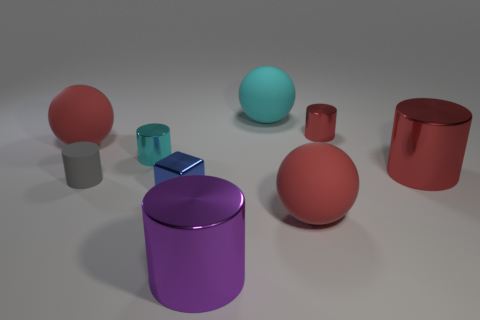There is a big matte sphere behind the big matte sphere that is to the left of the metal cylinder that is in front of the blue thing; what color is it?
Your answer should be very brief. Cyan. There is a cylinder behind the tiny cyan object; what color is it?
Provide a short and direct response. Red. What color is the metallic cylinder that is the same size as the purple metal thing?
Offer a terse response. Red. Is the size of the blue metal object the same as the cyan sphere?
Your answer should be very brief. No. There is a small gray object; how many blue blocks are left of it?
Offer a terse response. 0. What number of objects are red things that are in front of the small metallic block or big red objects?
Offer a very short reply. 3. Are there more red balls on the right side of the big cyan rubber ball than blue blocks in front of the big purple metallic cylinder?
Give a very brief answer. Yes. There is a gray matte thing; is its size the same as the shiny block that is on the left side of the big cyan matte ball?
Give a very brief answer. Yes. How many blocks are either small red metal things or large red shiny things?
Ensure brevity in your answer.  0. There is a cube that is made of the same material as the tiny red thing; what size is it?
Your answer should be compact. Small. 